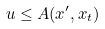<formula> <loc_0><loc_0><loc_500><loc_500>u \leq A ( x ^ { \prime } , x _ { t } )</formula> 